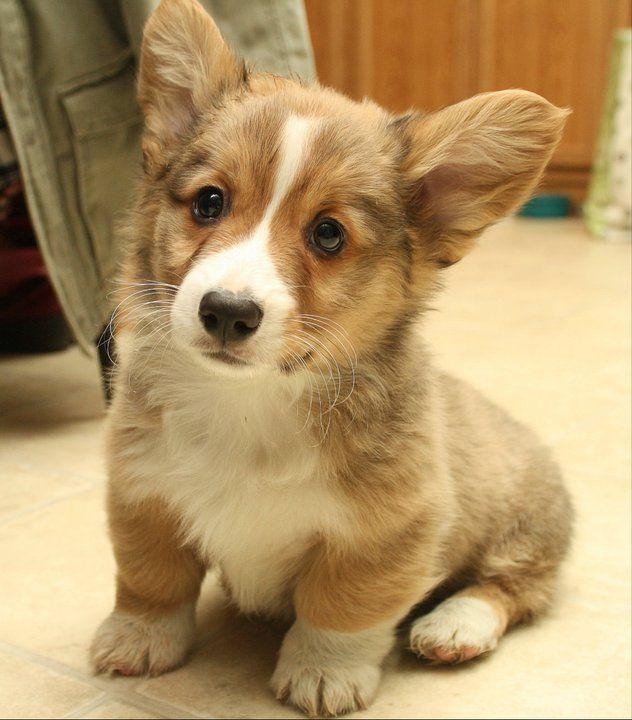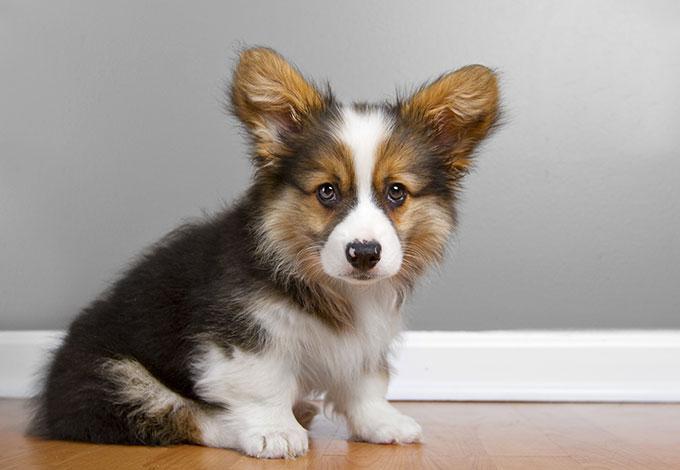The first image is the image on the left, the second image is the image on the right. Assess this claim about the two images: "An image shows at least three similarly sized dogs posed in a row.". Correct or not? Answer yes or no. No. The first image is the image on the left, the second image is the image on the right. Examine the images to the left and right. Is the description "There is a dog in the right image on a wooden surface." accurate? Answer yes or no. Yes. The first image is the image on the left, the second image is the image on the right. Evaluate the accuracy of this statement regarding the images: "All dogs are on a natural surface outside.". Is it true? Answer yes or no. No. 